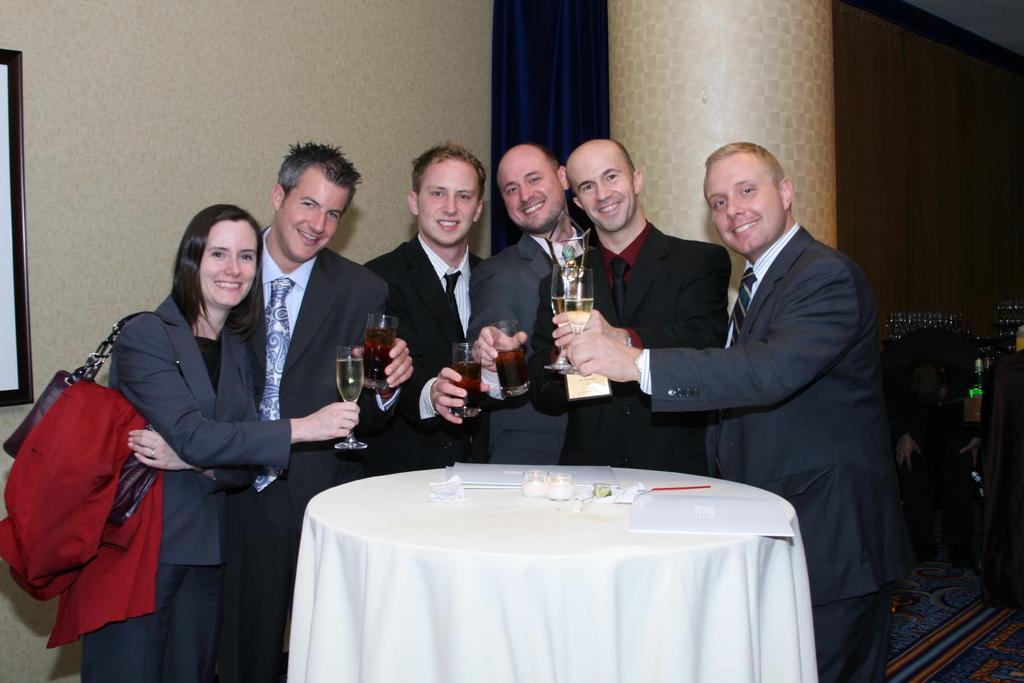Who or what is present in the image? There are people in the image. What are the people doing in the image? The people are standing in the image. What objects are the people holding in their hands? The people are holding wine glasses in their hands. What direction are the people facing in the image? The provided facts do not specify the direction the people are facing, so it cannot be determined from the image. What type of ink is being used to write on the wine glasses in the image? There is no indication in the image that the wine glasses are being used for writing, nor is there any mention of ink. 